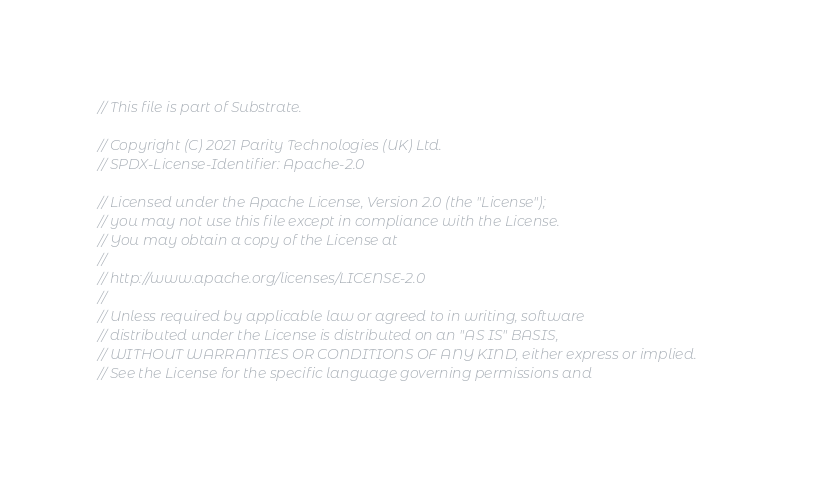<code> <loc_0><loc_0><loc_500><loc_500><_Rust_>// This file is part of Substrate.

// Copyright (C) 2021 Parity Technologies (UK) Ltd.
// SPDX-License-Identifier: Apache-2.0

// Licensed under the Apache License, Version 2.0 (the "License");
// you may not use this file except in compliance with the License.
// You may obtain a copy of the License at
//
// http://www.apache.org/licenses/LICENSE-2.0
//
// Unless required by applicable law or agreed to in writing, software
// distributed under the License is distributed on an "AS IS" BASIS,
// WITHOUT WARRANTIES OR CONDITIONS OF ANY KIND, either express or implied.
// See the License for the specific language governing permissions and</code> 